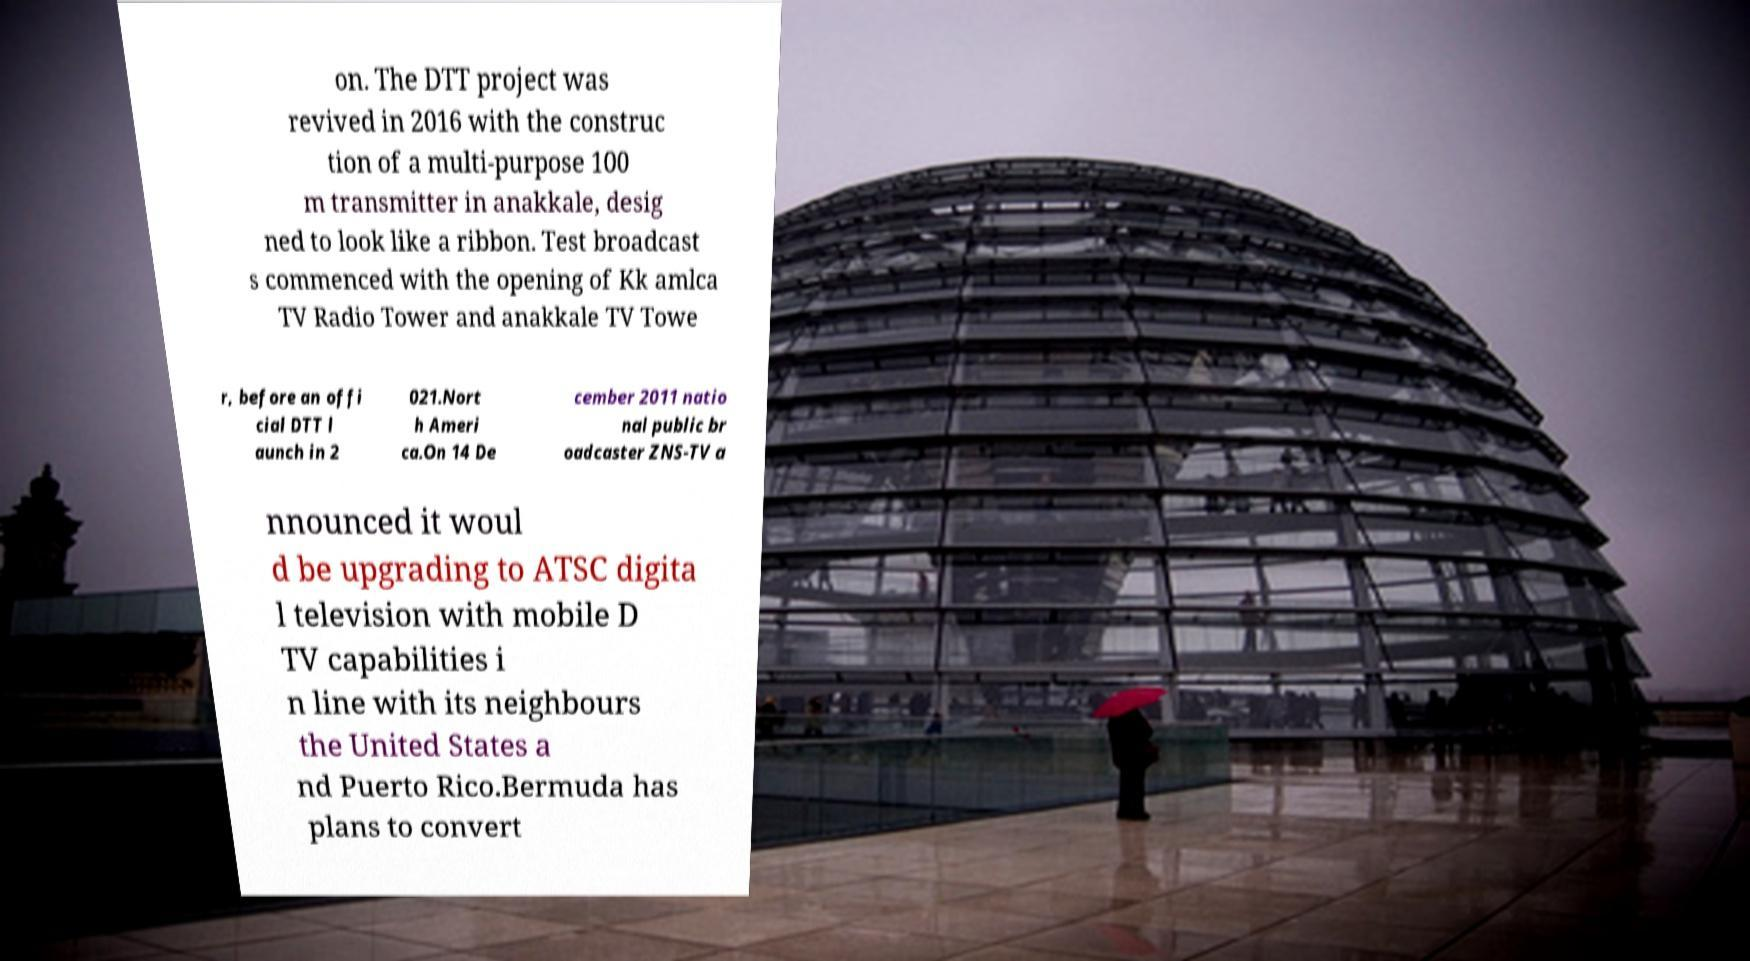I need the written content from this picture converted into text. Can you do that? on. The DTT project was revived in 2016 with the construc tion of a multi-purpose 100 m transmitter in anakkale, desig ned to look like a ribbon. Test broadcast s commenced with the opening of Kk amlca TV Radio Tower and anakkale TV Towe r, before an offi cial DTT l aunch in 2 021.Nort h Ameri ca.On 14 De cember 2011 natio nal public br oadcaster ZNS-TV a nnounced it woul d be upgrading to ATSC digita l television with mobile D TV capabilities i n line with its neighbours the United States a nd Puerto Rico.Bermuda has plans to convert 